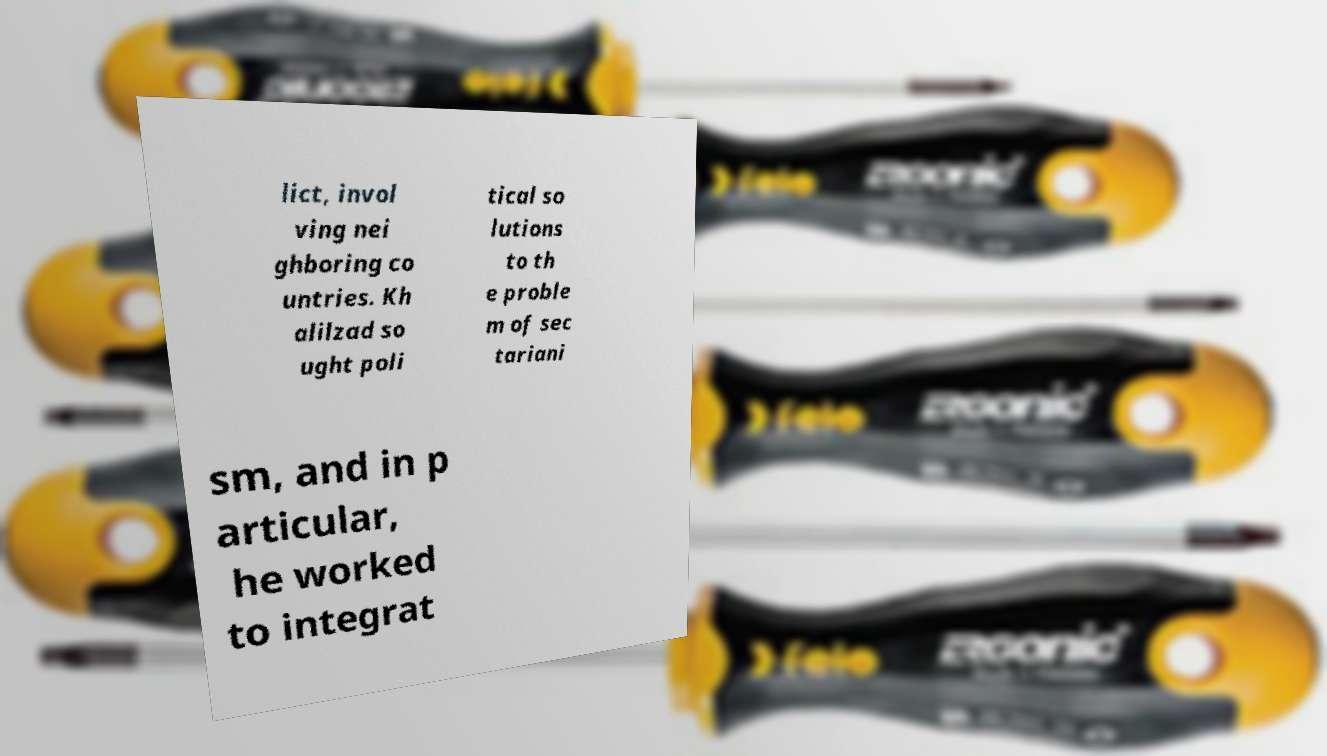What messages or text are displayed in this image? I need them in a readable, typed format. lict, invol ving nei ghboring co untries. Kh alilzad so ught poli tical so lutions to th e proble m of sec tariani sm, and in p articular, he worked to integrat 